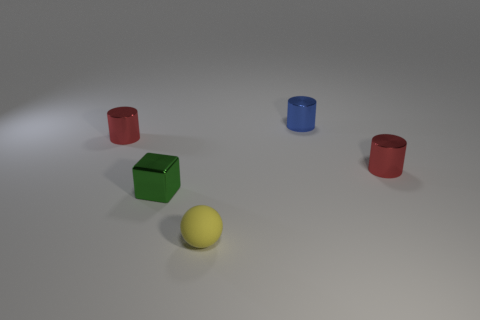Subtract all red cylinders. How many cylinders are left? 1 Add 2 tiny shiny things. How many objects exist? 7 Subtract all blue cylinders. How many cylinders are left? 2 Subtract all cubes. How many objects are left? 4 Subtract all cyan cylinders. Subtract all yellow balls. How many cylinders are left? 3 Subtract all yellow cubes. How many gray spheres are left? 0 Subtract all small yellow objects. Subtract all tiny cylinders. How many objects are left? 1 Add 5 green things. How many green things are left? 6 Add 5 matte objects. How many matte objects exist? 6 Subtract 0 brown cubes. How many objects are left? 5 